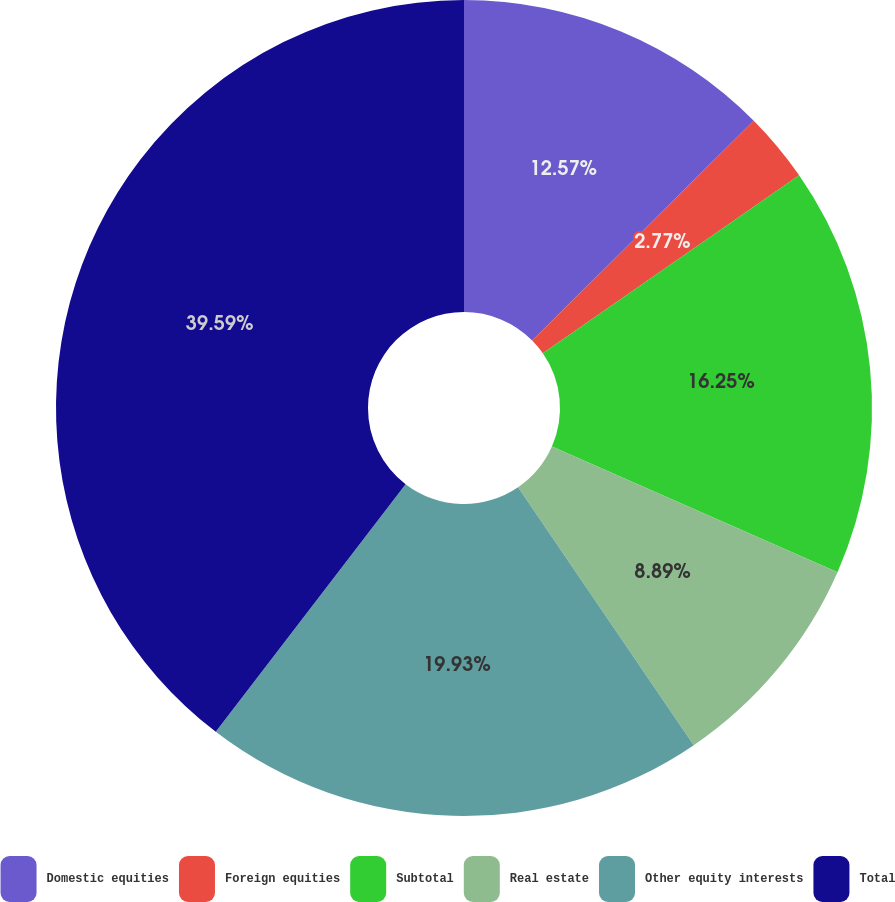Convert chart. <chart><loc_0><loc_0><loc_500><loc_500><pie_chart><fcel>Domestic equities<fcel>Foreign equities<fcel>Subtotal<fcel>Real estate<fcel>Other equity interests<fcel>Total<nl><fcel>12.57%<fcel>2.77%<fcel>16.25%<fcel>8.89%<fcel>19.93%<fcel>39.59%<nl></chart> 